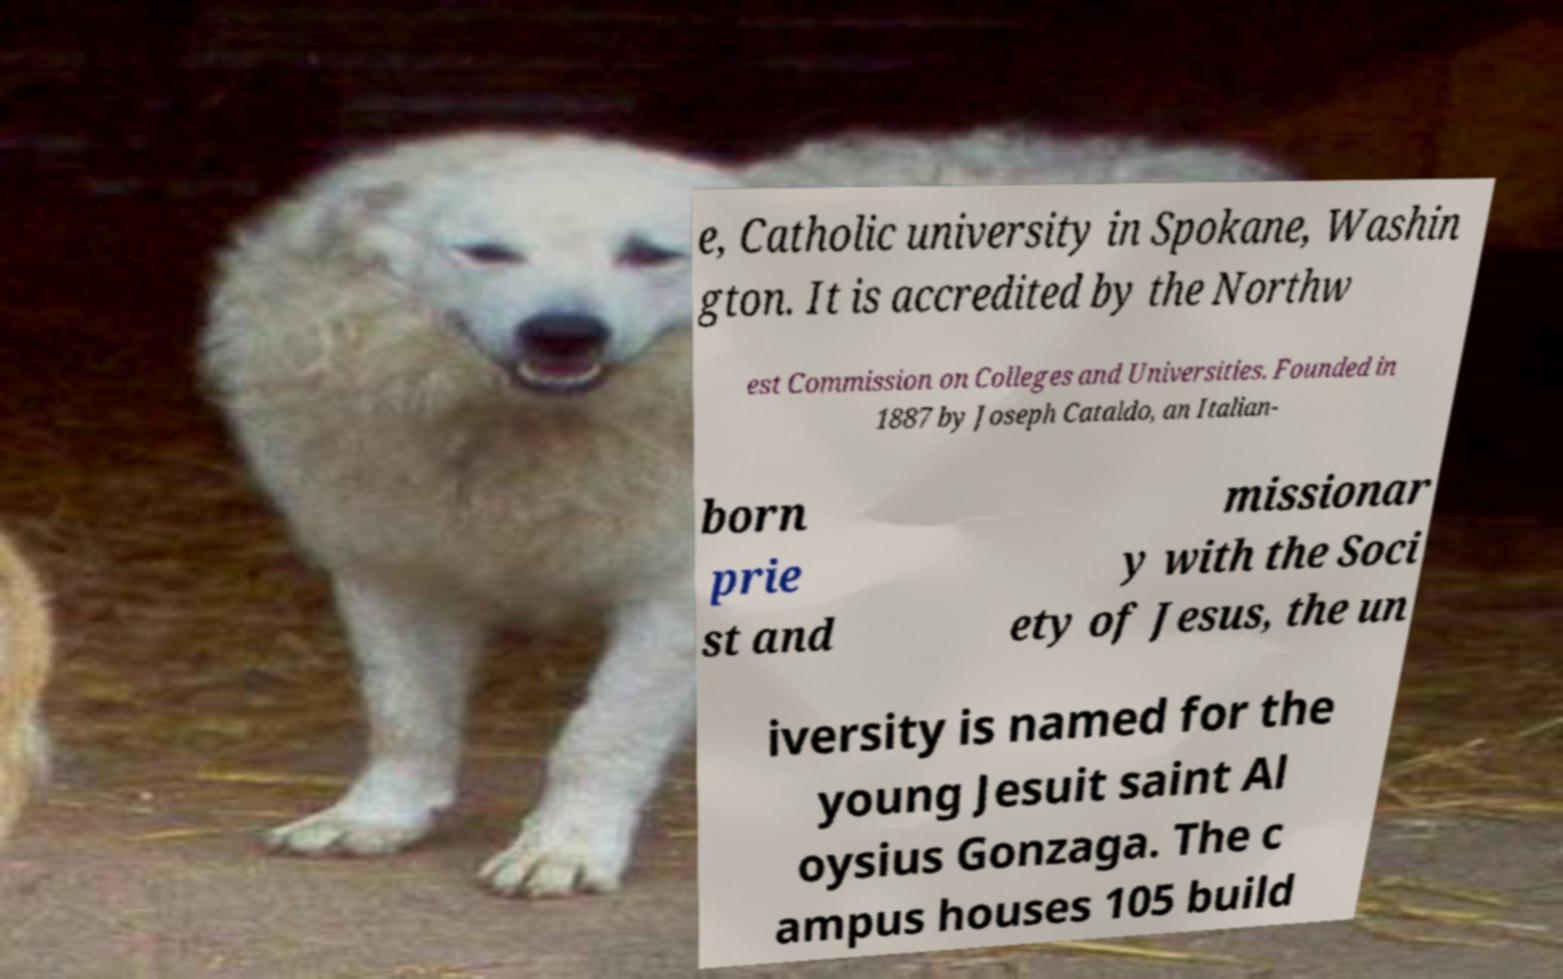Please identify and transcribe the text found in this image. e, Catholic university in Spokane, Washin gton. It is accredited by the Northw est Commission on Colleges and Universities. Founded in 1887 by Joseph Cataldo, an Italian- born prie st and missionar y with the Soci ety of Jesus, the un iversity is named for the young Jesuit saint Al oysius Gonzaga. The c ampus houses 105 build 